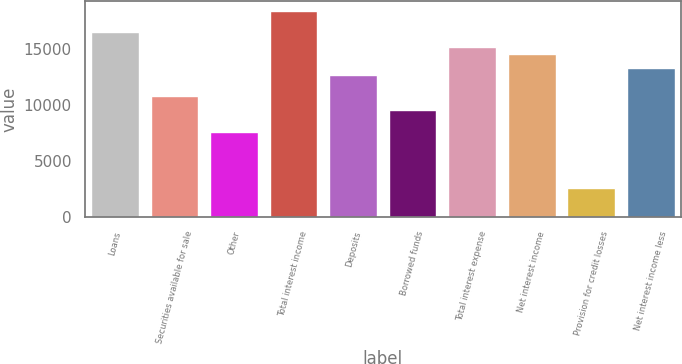Convert chart. <chart><loc_0><loc_0><loc_500><loc_500><bar_chart><fcel>Loans<fcel>Securities available for sale<fcel>Other<fcel>Total interest income<fcel>Deposits<fcel>Borrowed funds<fcel>Total interest expense<fcel>Net interest income<fcel>Provision for credit losses<fcel>Net interest income less<nl><fcel>16436.3<fcel>10749.8<fcel>7590.69<fcel>18331.8<fcel>12645.3<fcel>9486.18<fcel>15172.6<fcel>14540.8<fcel>2536.05<fcel>13277.2<nl></chart> 